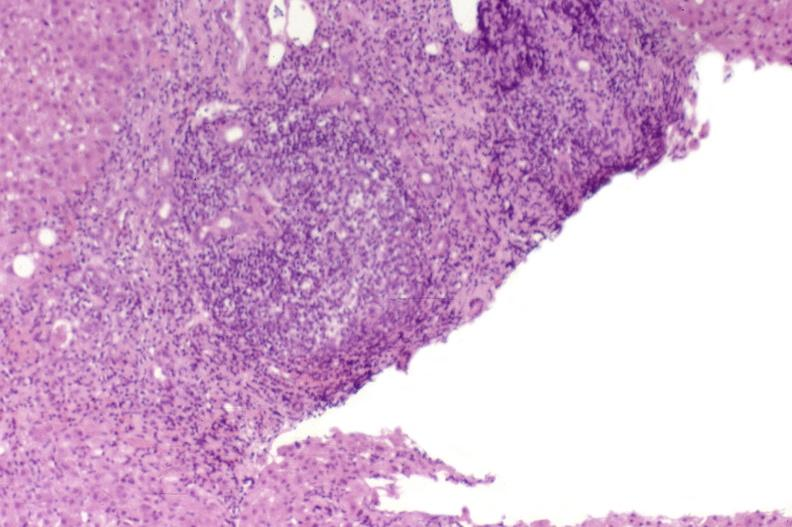does macerated stillborn show recurrent hepatitis c virus?
Answer the question using a single word or phrase. No 